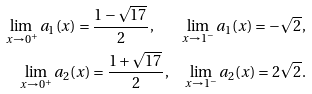Convert formula to latex. <formula><loc_0><loc_0><loc_500><loc_500>\lim _ { x \to 0 ^ { + } } a _ { 1 } ( x ) = \frac { 1 - \sqrt { 1 7 } \, } 2 , \quad \lim _ { x \to 1 ^ { - } } a _ { 1 } ( x ) = - \sqrt { 2 } \, , \\ \lim _ { x \to 0 ^ { + } } a _ { 2 } ( x ) = \frac { 1 + \sqrt { 1 7 } \, } 2 , \quad \lim _ { x \to 1 ^ { - } } a _ { 2 } ( x ) = 2 \sqrt { 2 } \, .</formula> 